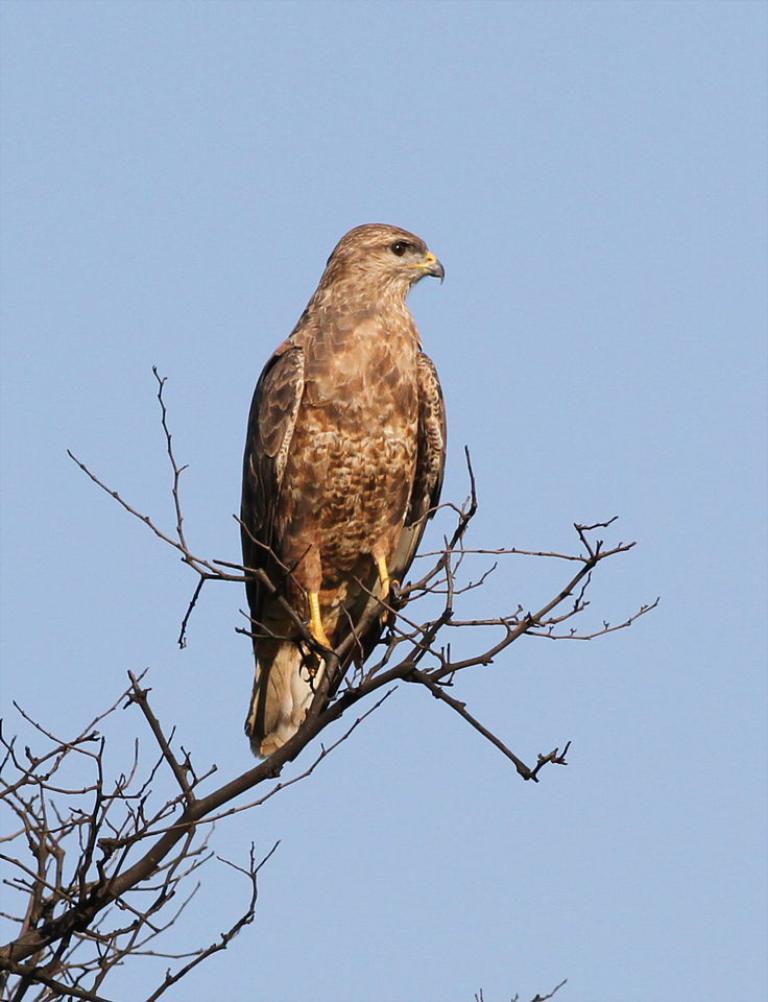Can you describe this image briefly? In this picture we can observe a bird on the branch of the dried tree. The bird is in brown color. In the background there is a sky. 